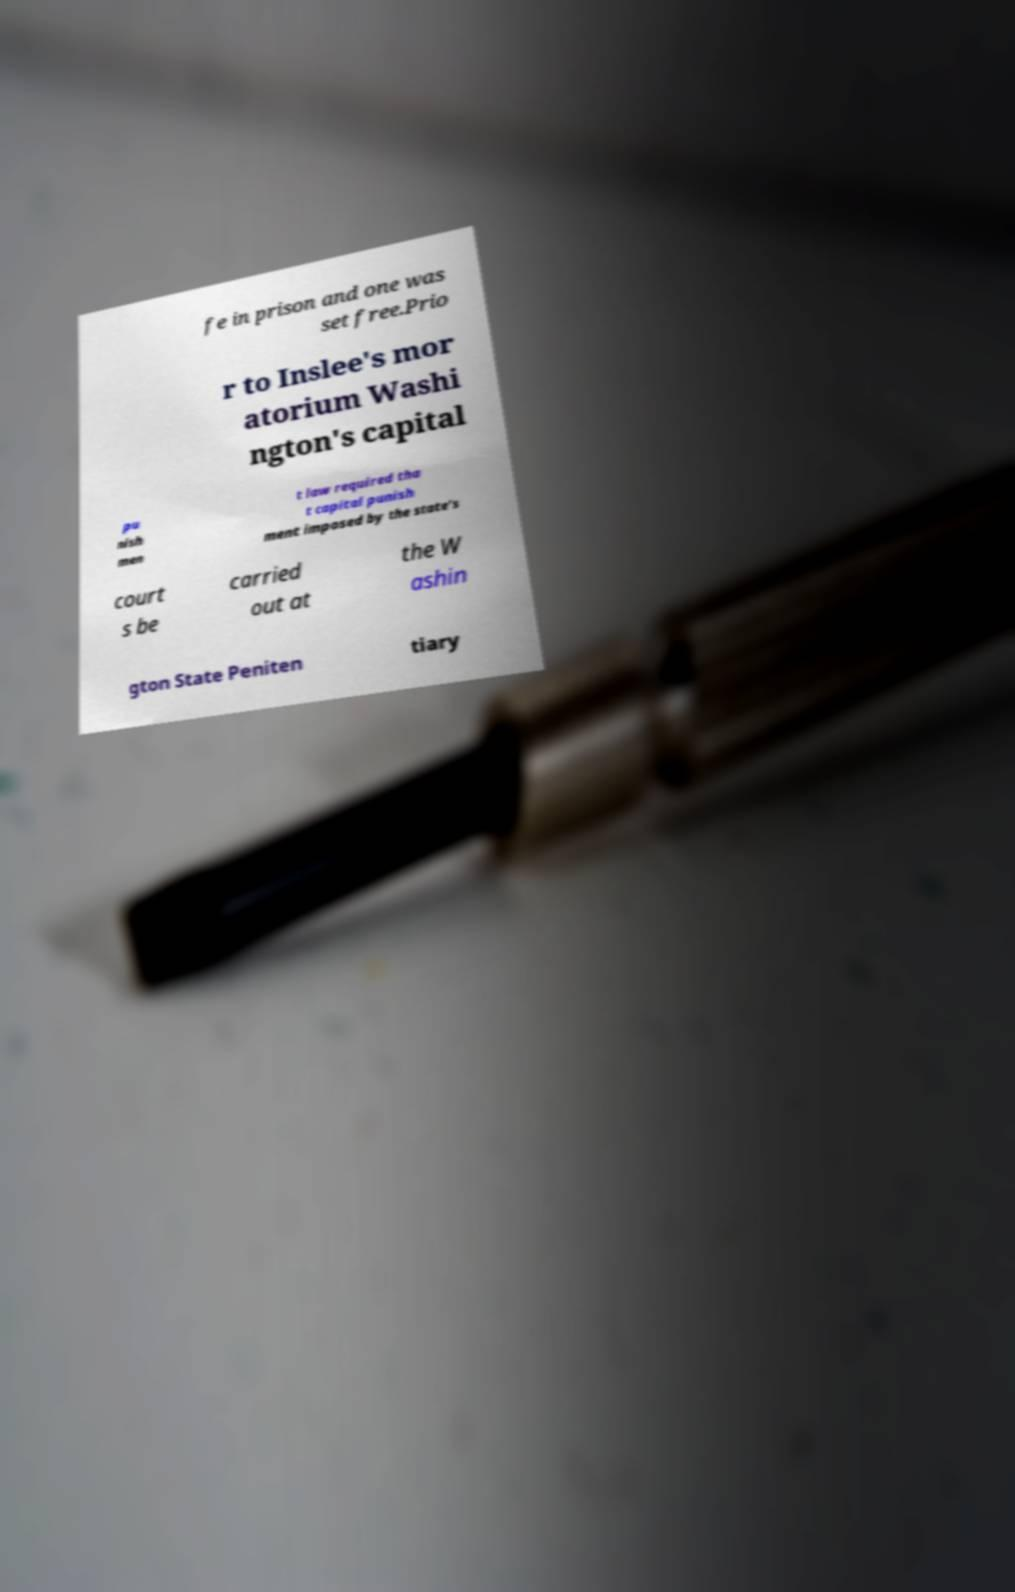For documentation purposes, I need the text within this image transcribed. Could you provide that? fe in prison and one was set free.Prio r to Inslee's mor atorium Washi ngton's capital pu nish men t law required tha t capital punish ment imposed by the state's court s be carried out at the W ashin gton State Peniten tiary 